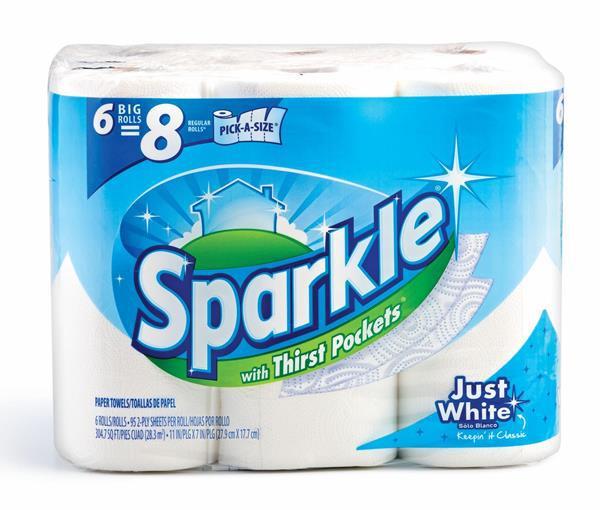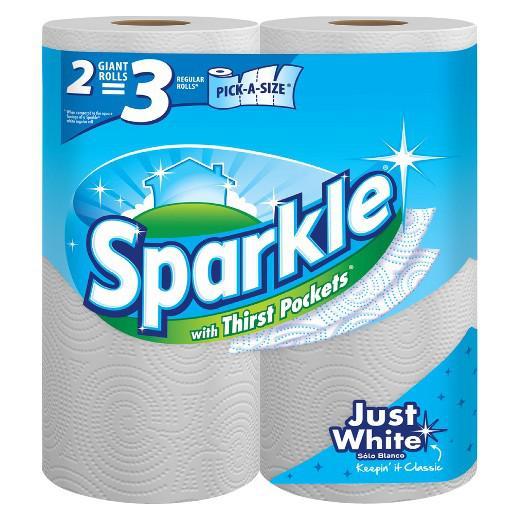The first image is the image on the left, the second image is the image on the right. Considering the images on both sides, is "One image features a single package of six rolls in two rows of three." valid? Answer yes or no. Yes. The first image is the image on the left, the second image is the image on the right. Considering the images on both sides, is "There are six rolls of paper towel in the package in the image on the left." valid? Answer yes or no. Yes. 